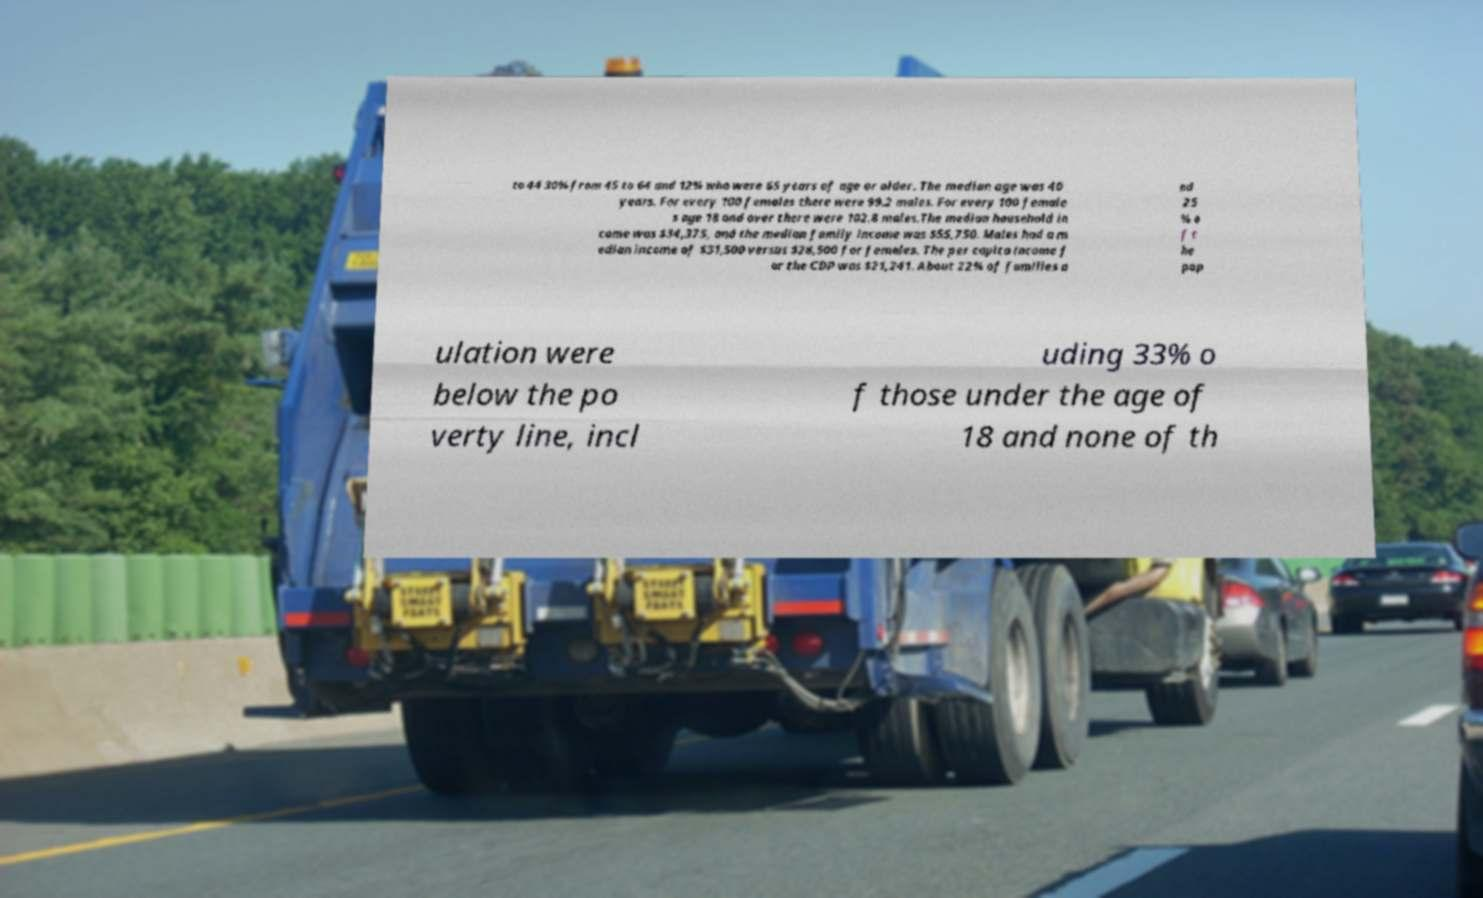There's text embedded in this image that I need extracted. Can you transcribe it verbatim? to 44 30% from 45 to 64 and 12% who were 65 years of age or older. The median age was 40 years. For every 100 females there were 99.2 males. For every 100 female s age 18 and over there were 102.8 males.The median household in come was $34,375, and the median family income was $55,750. Males had a m edian income of $31,500 versus $28,500 for females. The per capita income f or the CDP was $21,241. About 22% of families a nd 25 % o f t he pop ulation were below the po verty line, incl uding 33% o f those under the age of 18 and none of th 